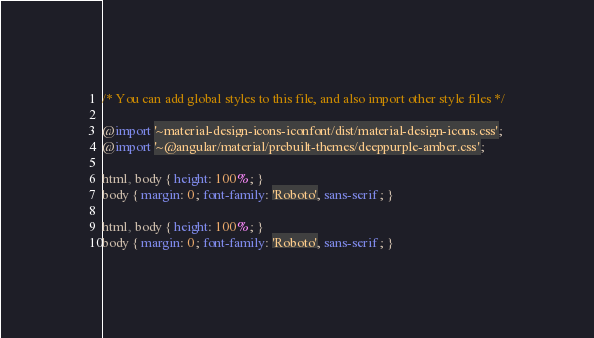Convert code to text. <code><loc_0><loc_0><loc_500><loc_500><_CSS_>
/* You can add global styles to this file, and also import other style files */

@import '~material-design-icons-iconfont/dist/material-design-icons.css';
@import '~@angular/material/prebuilt-themes/deeppurple-amber.css';

html, body { height: 100%; }
body { margin: 0; font-family: 'Roboto', sans-serif; }

html, body { height: 100%; }
body { margin: 0; font-family: 'Roboto', sans-serif; }
</code> 